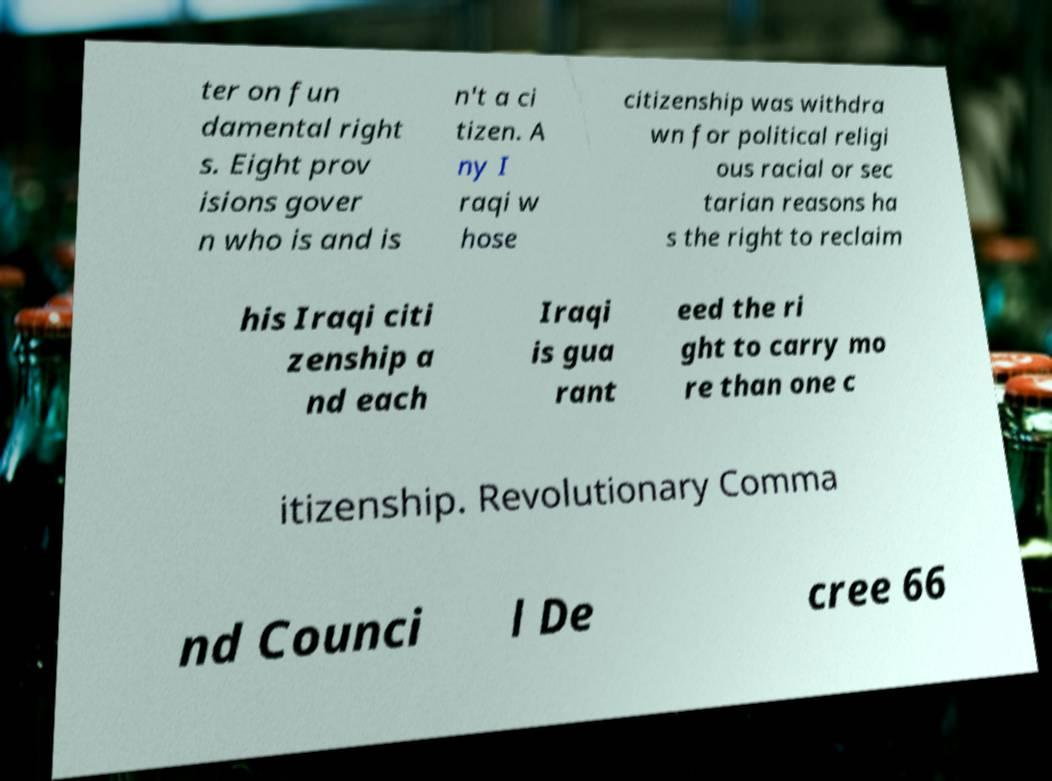I need the written content from this picture converted into text. Can you do that? ter on fun damental right s. Eight prov isions gover n who is and is n't a ci tizen. A ny I raqi w hose citizenship was withdra wn for political religi ous racial or sec tarian reasons ha s the right to reclaim his Iraqi citi zenship a nd each Iraqi is gua rant eed the ri ght to carry mo re than one c itizenship. Revolutionary Comma nd Counci l De cree 66 